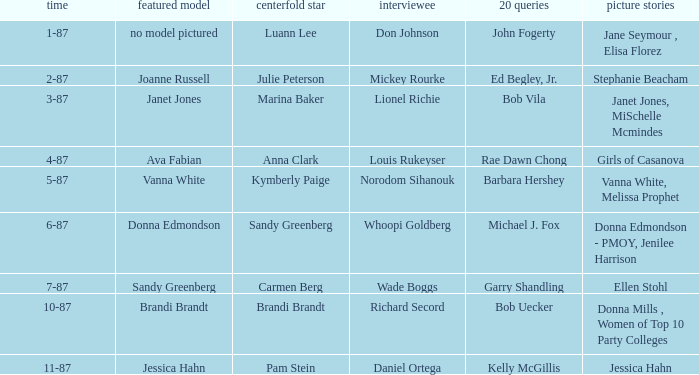When was the Kymberly Paige the Centerfold? 5-87. 